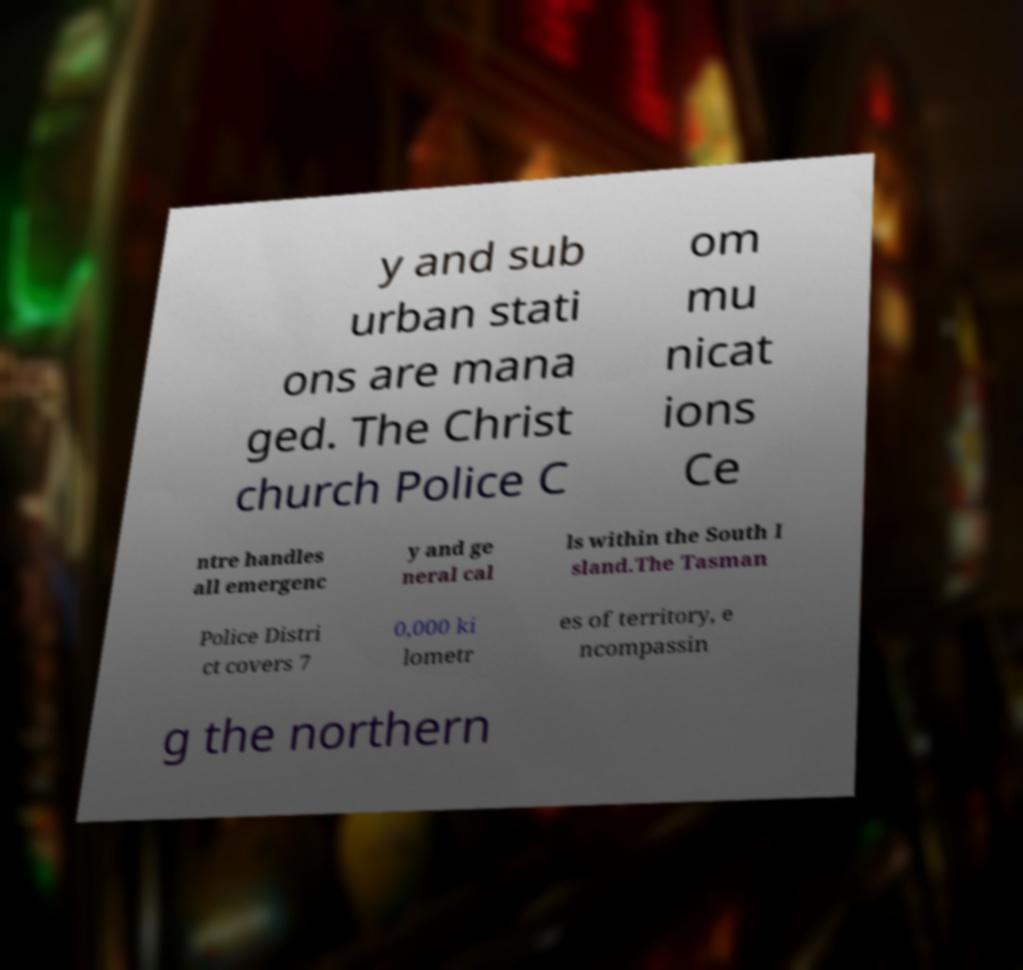Could you extract and type out the text from this image? y and sub urban stati ons are mana ged. The Christ church Police C om mu nicat ions Ce ntre handles all emergenc y and ge neral cal ls within the South I sland.The Tasman Police Distri ct covers 7 0,000 ki lometr es of territory, e ncompassin g the northern 